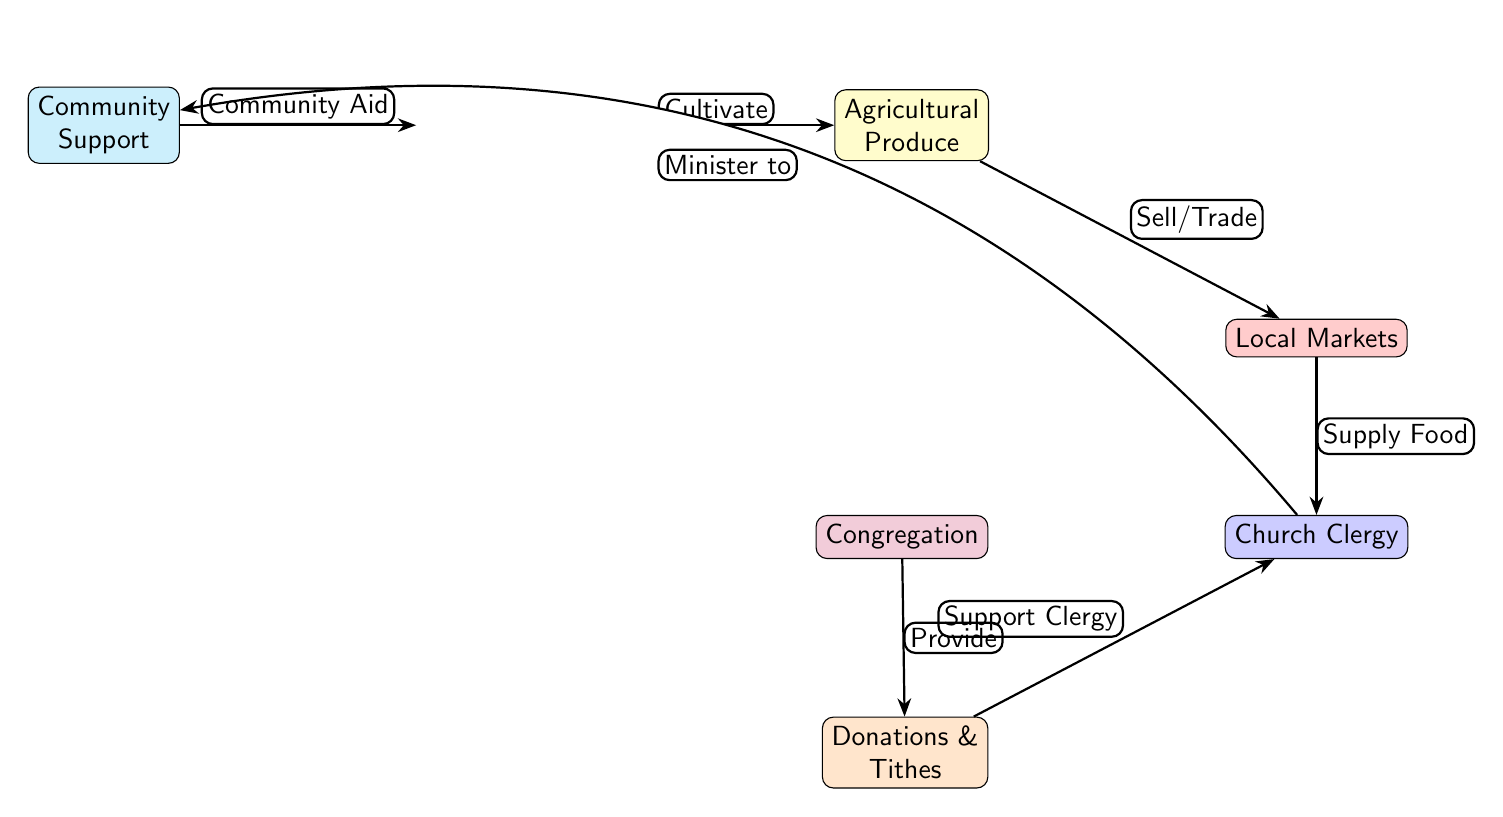What is the first node in the diagram? The first node in the diagram is "Local Farmers". This can be determined by identifying the node that is positioned on the leftmost side of the diagram.
Answer: Local Farmers How many nodes are there in total? Counting all the distinct nodes present in the diagram, we find a total of 6 nodes: Local Farmers, Agricultural Produce, Local Markets, Church Clergy, Congregation, and Donations & Tithes.
Answer: 6 What does the "Local Markets" node receive from the "Agricultural Produce" node? The "Local Markets" node receives "Sell/Trade" from the "Agricultural Produce" node. This is indicated by the directional edge labeled "Sell/Trade" pointing from Agricultural Produce to Local Markets.
Answer: Sell/Trade Which node provides donations to the Church Clergy? The "Congregation" node provides donations to the Church Clergy. This is shown by the edge from the Congregation pointing towards Church Clergy labeled "Provide".
Answer: Congregation What relationship exists between Church Clergy and Local Markets? Church Clergy receives "Supply Food" from Local Markets. This relationship is denoted by the arrow pointing from Local Markets to Church Clergy with the label "Supply Food".
Answer: Supply Food Which node supports the Local Farmers through community aid? The "Church Clergy" node supports the Local Farmers through community aid. This connection is illustrated by the edge labeled "Minister to" that bends towards the Community Support node, which subsequently provides community aid back to the farmers.
Answer: Church Clergy What type of support do donations and tithes provide? Donations & Tithes provide "Support Clergy". This is indicated by the edge leading from Donations & Tithes to Church Clergy labeled "Support Clergy".
Answer: Support Clergy How does the Community Support influence the connection to Local Farmers? Community Support influences Local Farmers by providing "Community Aid". This is depicted by the edge from Community Support directing back to Local Farmers indicating a reciprocal support system.
Answer: Community Aid What is the final node in the diagram? The final node in the diagram is "Community Support". This can be seen as it is positioned at the left side after the returning arrows indicating its role in supporting both the farmers and the clergy.
Answer: Community Support 